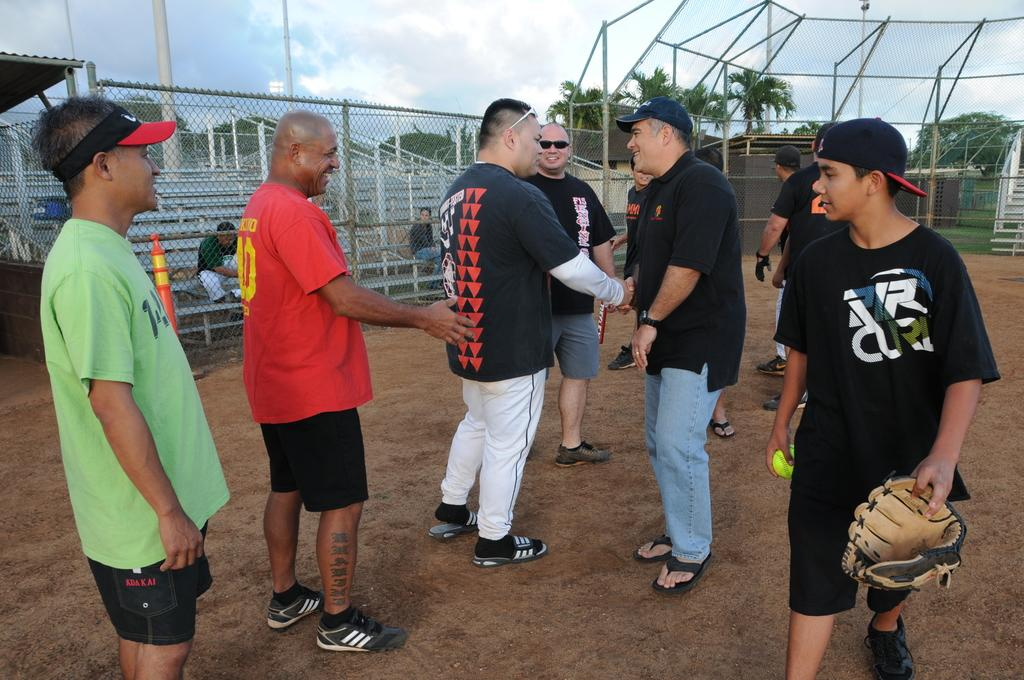<image>
Relay a brief, clear account of the picture shown. A young man wearing a black shirt that says RIP on it is carrying a baseball glove. 